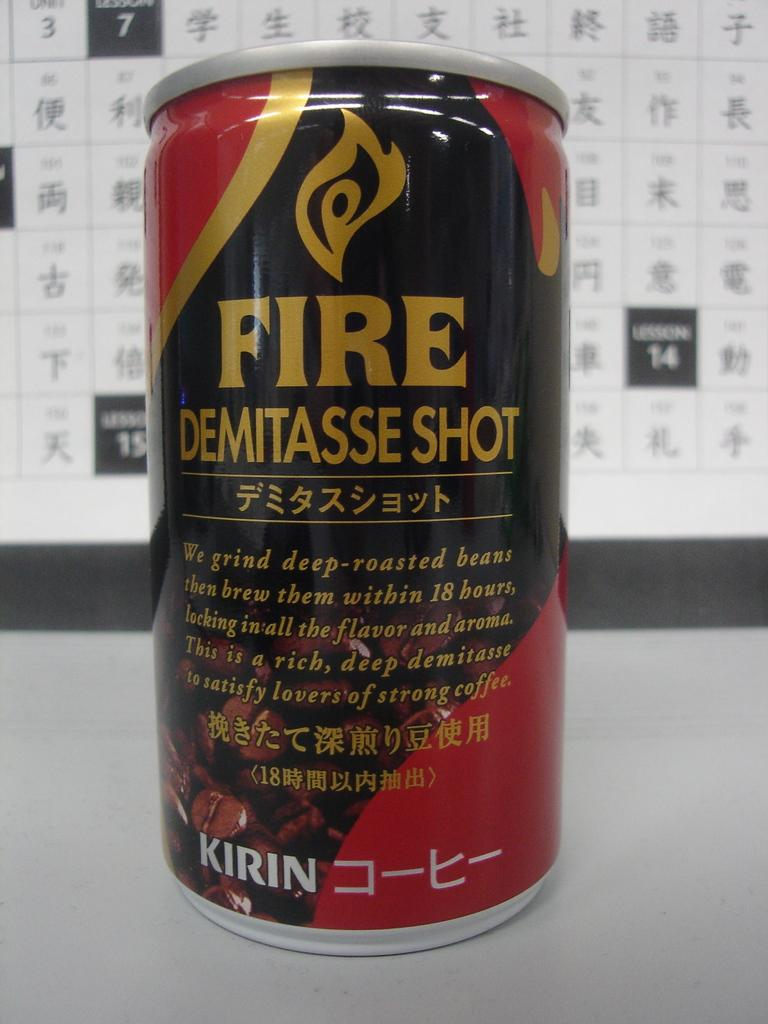<image>
Offer a succinct explanation of the picture presented. It's a can of cold coffee style drink made from deep-roasted beans. 